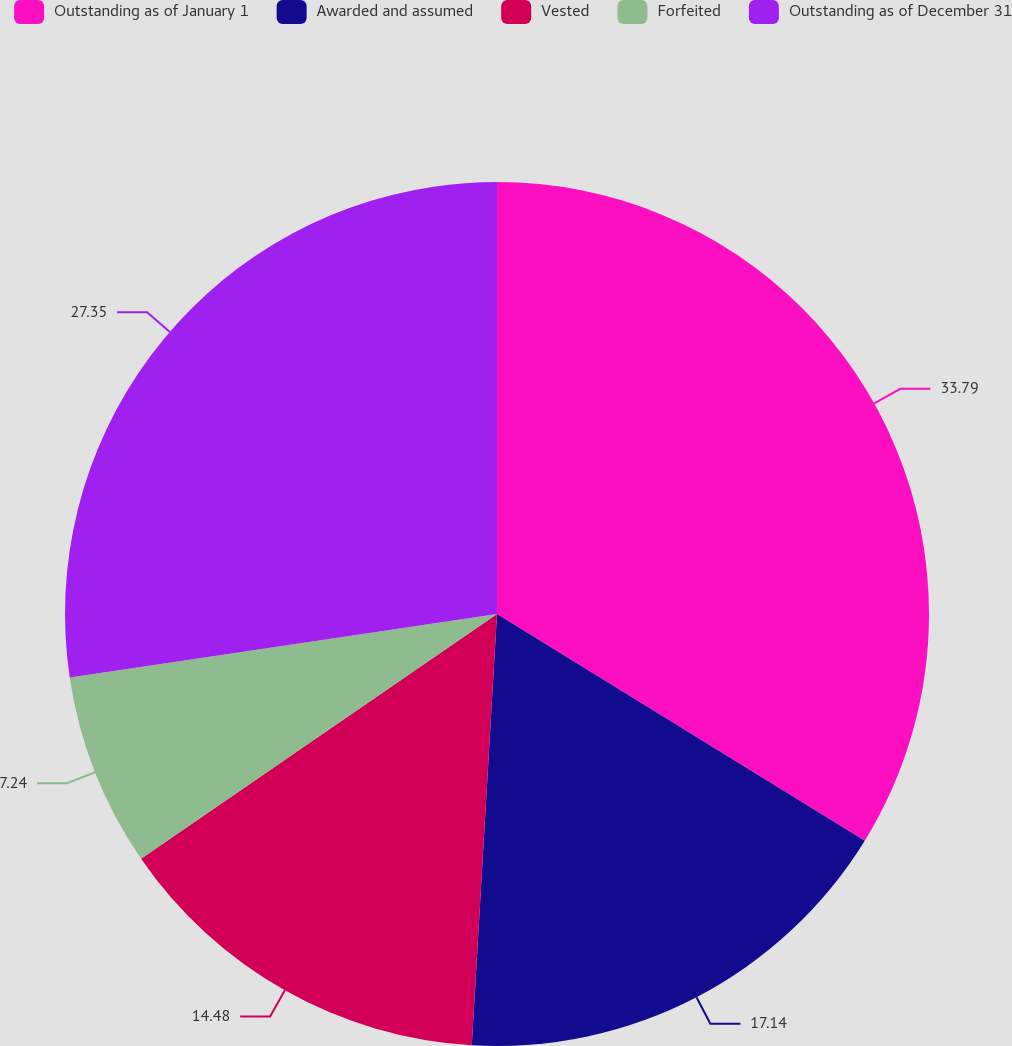Convert chart. <chart><loc_0><loc_0><loc_500><loc_500><pie_chart><fcel>Outstanding as of January 1<fcel>Awarded and assumed<fcel>Vested<fcel>Forfeited<fcel>Outstanding as of December 31<nl><fcel>33.79%<fcel>17.14%<fcel>14.48%<fcel>7.24%<fcel>27.35%<nl></chart> 